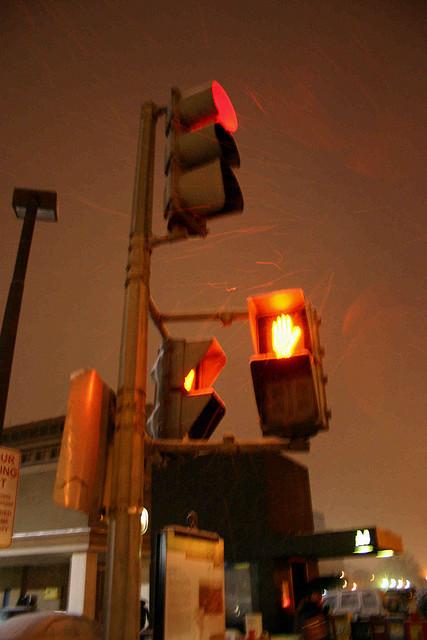Is this the country?
Be succinct. No. Are there lights on in the picture?
Give a very brief answer. Yes. What is the shape that says not to walk?
Answer briefly. Hand. Is that a forest in the background?
Be succinct. No. 